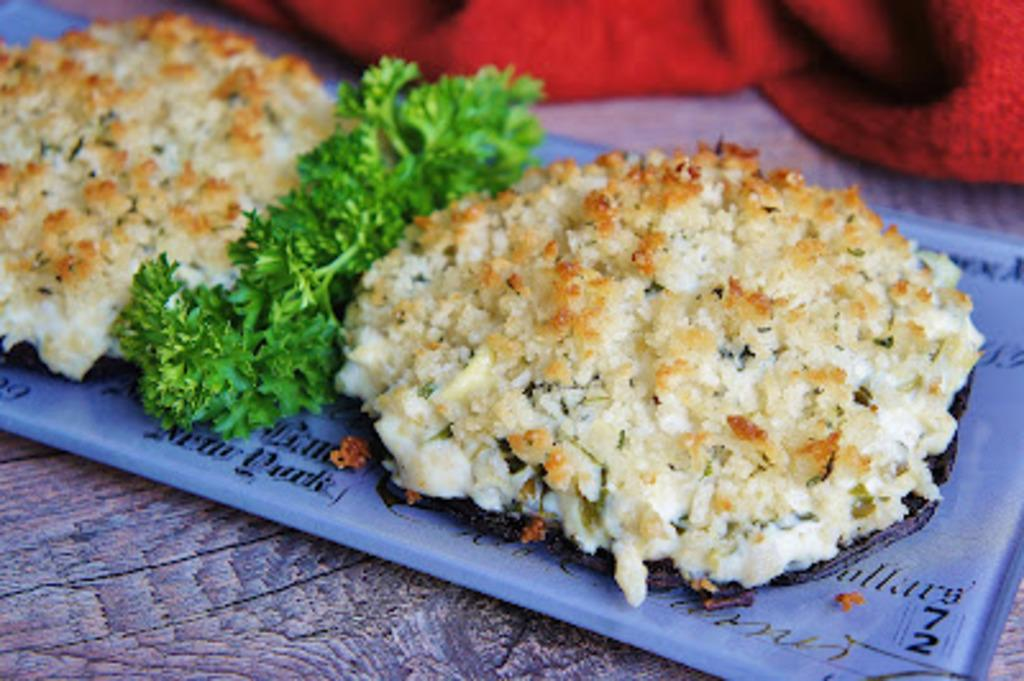What is on the plate that is visible in the image? There are food items served on a plate in the image. What is the plate resting on in the image? The plate is on a wooden surface. Can you describe the red object in the image? There is a red color object on the top side of the image. What type of temper is the person displaying on the stage in the image? There is no person or stage present in the image; it only features food items on a plate and a red object. 